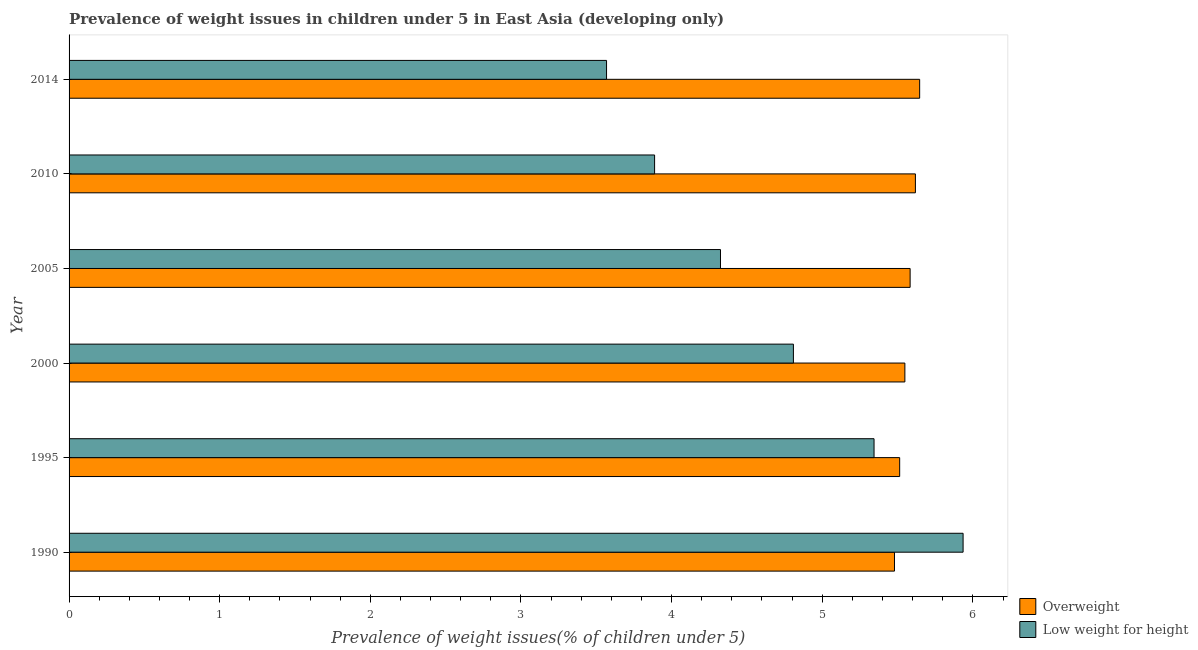How many bars are there on the 2nd tick from the bottom?
Ensure brevity in your answer.  2. What is the label of the 2nd group of bars from the top?
Offer a terse response. 2010. What is the percentage of overweight children in 2005?
Provide a succinct answer. 5.58. Across all years, what is the maximum percentage of underweight children?
Ensure brevity in your answer.  5.93. Across all years, what is the minimum percentage of underweight children?
Your answer should be very brief. 3.57. In which year was the percentage of overweight children maximum?
Give a very brief answer. 2014. In which year was the percentage of overweight children minimum?
Ensure brevity in your answer.  1990. What is the total percentage of underweight children in the graph?
Provide a succinct answer. 27.87. What is the difference between the percentage of overweight children in 2005 and that in 2010?
Offer a very short reply. -0.04. What is the difference between the percentage of underweight children in 2014 and the percentage of overweight children in 1990?
Your answer should be compact. -1.91. What is the average percentage of underweight children per year?
Keep it short and to the point. 4.64. In the year 2014, what is the difference between the percentage of overweight children and percentage of underweight children?
Ensure brevity in your answer.  2.08. In how many years, is the percentage of overweight children greater than 4.4 %?
Keep it short and to the point. 6. What is the ratio of the percentage of underweight children in 1990 to that in 2000?
Offer a very short reply. 1.23. What is the difference between the highest and the second highest percentage of overweight children?
Your answer should be compact. 0.03. What is the difference between the highest and the lowest percentage of underweight children?
Your answer should be very brief. 2.37. In how many years, is the percentage of overweight children greater than the average percentage of overweight children taken over all years?
Provide a short and direct response. 3. What does the 1st bar from the top in 2005 represents?
Keep it short and to the point. Low weight for height. What does the 2nd bar from the bottom in 2000 represents?
Give a very brief answer. Low weight for height. How many bars are there?
Give a very brief answer. 12. Are all the bars in the graph horizontal?
Provide a short and direct response. Yes. Are the values on the major ticks of X-axis written in scientific E-notation?
Make the answer very short. No. Does the graph contain grids?
Your answer should be compact. No. How many legend labels are there?
Give a very brief answer. 2. How are the legend labels stacked?
Provide a succinct answer. Vertical. What is the title of the graph?
Give a very brief answer. Prevalence of weight issues in children under 5 in East Asia (developing only). What is the label or title of the X-axis?
Offer a very short reply. Prevalence of weight issues(% of children under 5). What is the Prevalence of weight issues(% of children under 5) in Overweight in 1990?
Your answer should be compact. 5.48. What is the Prevalence of weight issues(% of children under 5) of Low weight for height in 1990?
Your answer should be compact. 5.93. What is the Prevalence of weight issues(% of children under 5) in Overweight in 1995?
Your answer should be compact. 5.51. What is the Prevalence of weight issues(% of children under 5) of Low weight for height in 1995?
Keep it short and to the point. 5.34. What is the Prevalence of weight issues(% of children under 5) in Overweight in 2000?
Your answer should be compact. 5.55. What is the Prevalence of weight issues(% of children under 5) in Low weight for height in 2000?
Ensure brevity in your answer.  4.81. What is the Prevalence of weight issues(% of children under 5) of Overweight in 2005?
Give a very brief answer. 5.58. What is the Prevalence of weight issues(% of children under 5) of Low weight for height in 2005?
Your answer should be compact. 4.32. What is the Prevalence of weight issues(% of children under 5) in Overweight in 2010?
Offer a very short reply. 5.62. What is the Prevalence of weight issues(% of children under 5) in Low weight for height in 2010?
Your response must be concise. 3.89. What is the Prevalence of weight issues(% of children under 5) of Overweight in 2014?
Ensure brevity in your answer.  5.65. What is the Prevalence of weight issues(% of children under 5) of Low weight for height in 2014?
Offer a terse response. 3.57. Across all years, what is the maximum Prevalence of weight issues(% of children under 5) of Overweight?
Provide a short and direct response. 5.65. Across all years, what is the maximum Prevalence of weight issues(% of children under 5) in Low weight for height?
Your answer should be compact. 5.93. Across all years, what is the minimum Prevalence of weight issues(% of children under 5) in Overweight?
Offer a very short reply. 5.48. Across all years, what is the minimum Prevalence of weight issues(% of children under 5) of Low weight for height?
Provide a succinct answer. 3.57. What is the total Prevalence of weight issues(% of children under 5) in Overweight in the graph?
Offer a very short reply. 33.39. What is the total Prevalence of weight issues(% of children under 5) in Low weight for height in the graph?
Your response must be concise. 27.87. What is the difference between the Prevalence of weight issues(% of children under 5) of Overweight in 1990 and that in 1995?
Keep it short and to the point. -0.03. What is the difference between the Prevalence of weight issues(% of children under 5) in Low weight for height in 1990 and that in 1995?
Offer a very short reply. 0.59. What is the difference between the Prevalence of weight issues(% of children under 5) of Overweight in 1990 and that in 2000?
Your answer should be very brief. -0.07. What is the difference between the Prevalence of weight issues(% of children under 5) in Low weight for height in 1990 and that in 2000?
Offer a very short reply. 1.13. What is the difference between the Prevalence of weight issues(% of children under 5) in Overweight in 1990 and that in 2005?
Give a very brief answer. -0.1. What is the difference between the Prevalence of weight issues(% of children under 5) of Low weight for height in 1990 and that in 2005?
Give a very brief answer. 1.61. What is the difference between the Prevalence of weight issues(% of children under 5) of Overweight in 1990 and that in 2010?
Provide a succinct answer. -0.14. What is the difference between the Prevalence of weight issues(% of children under 5) of Low weight for height in 1990 and that in 2010?
Provide a short and direct response. 2.05. What is the difference between the Prevalence of weight issues(% of children under 5) of Overweight in 1990 and that in 2014?
Your answer should be very brief. -0.17. What is the difference between the Prevalence of weight issues(% of children under 5) in Low weight for height in 1990 and that in 2014?
Provide a short and direct response. 2.37. What is the difference between the Prevalence of weight issues(% of children under 5) of Overweight in 1995 and that in 2000?
Your answer should be very brief. -0.03. What is the difference between the Prevalence of weight issues(% of children under 5) in Low weight for height in 1995 and that in 2000?
Provide a succinct answer. 0.54. What is the difference between the Prevalence of weight issues(% of children under 5) of Overweight in 1995 and that in 2005?
Offer a terse response. -0.07. What is the difference between the Prevalence of weight issues(% of children under 5) of Low weight for height in 1995 and that in 2005?
Offer a terse response. 1.02. What is the difference between the Prevalence of weight issues(% of children under 5) of Overweight in 1995 and that in 2010?
Your answer should be very brief. -0.1. What is the difference between the Prevalence of weight issues(% of children under 5) of Low weight for height in 1995 and that in 2010?
Make the answer very short. 1.46. What is the difference between the Prevalence of weight issues(% of children under 5) in Overweight in 1995 and that in 2014?
Make the answer very short. -0.13. What is the difference between the Prevalence of weight issues(% of children under 5) of Low weight for height in 1995 and that in 2014?
Your answer should be compact. 1.78. What is the difference between the Prevalence of weight issues(% of children under 5) in Overweight in 2000 and that in 2005?
Keep it short and to the point. -0.03. What is the difference between the Prevalence of weight issues(% of children under 5) in Low weight for height in 2000 and that in 2005?
Keep it short and to the point. 0.48. What is the difference between the Prevalence of weight issues(% of children under 5) in Overweight in 2000 and that in 2010?
Offer a terse response. -0.07. What is the difference between the Prevalence of weight issues(% of children under 5) of Low weight for height in 2000 and that in 2010?
Keep it short and to the point. 0.92. What is the difference between the Prevalence of weight issues(% of children under 5) of Overweight in 2000 and that in 2014?
Offer a very short reply. -0.1. What is the difference between the Prevalence of weight issues(% of children under 5) in Low weight for height in 2000 and that in 2014?
Provide a succinct answer. 1.24. What is the difference between the Prevalence of weight issues(% of children under 5) of Overweight in 2005 and that in 2010?
Give a very brief answer. -0.04. What is the difference between the Prevalence of weight issues(% of children under 5) in Low weight for height in 2005 and that in 2010?
Your answer should be very brief. 0.44. What is the difference between the Prevalence of weight issues(% of children under 5) of Overweight in 2005 and that in 2014?
Offer a very short reply. -0.06. What is the difference between the Prevalence of weight issues(% of children under 5) in Low weight for height in 2005 and that in 2014?
Your response must be concise. 0.76. What is the difference between the Prevalence of weight issues(% of children under 5) of Overweight in 2010 and that in 2014?
Your answer should be compact. -0.03. What is the difference between the Prevalence of weight issues(% of children under 5) in Low weight for height in 2010 and that in 2014?
Give a very brief answer. 0.32. What is the difference between the Prevalence of weight issues(% of children under 5) in Overweight in 1990 and the Prevalence of weight issues(% of children under 5) in Low weight for height in 1995?
Your answer should be compact. 0.14. What is the difference between the Prevalence of weight issues(% of children under 5) in Overweight in 1990 and the Prevalence of weight issues(% of children under 5) in Low weight for height in 2000?
Give a very brief answer. 0.67. What is the difference between the Prevalence of weight issues(% of children under 5) in Overweight in 1990 and the Prevalence of weight issues(% of children under 5) in Low weight for height in 2005?
Give a very brief answer. 1.16. What is the difference between the Prevalence of weight issues(% of children under 5) in Overweight in 1990 and the Prevalence of weight issues(% of children under 5) in Low weight for height in 2010?
Offer a very short reply. 1.59. What is the difference between the Prevalence of weight issues(% of children under 5) of Overweight in 1990 and the Prevalence of weight issues(% of children under 5) of Low weight for height in 2014?
Your response must be concise. 1.91. What is the difference between the Prevalence of weight issues(% of children under 5) of Overweight in 1995 and the Prevalence of weight issues(% of children under 5) of Low weight for height in 2000?
Offer a terse response. 0.71. What is the difference between the Prevalence of weight issues(% of children under 5) of Overweight in 1995 and the Prevalence of weight issues(% of children under 5) of Low weight for height in 2005?
Offer a very short reply. 1.19. What is the difference between the Prevalence of weight issues(% of children under 5) in Overweight in 1995 and the Prevalence of weight issues(% of children under 5) in Low weight for height in 2010?
Keep it short and to the point. 1.63. What is the difference between the Prevalence of weight issues(% of children under 5) of Overweight in 1995 and the Prevalence of weight issues(% of children under 5) of Low weight for height in 2014?
Offer a terse response. 1.95. What is the difference between the Prevalence of weight issues(% of children under 5) of Overweight in 2000 and the Prevalence of weight issues(% of children under 5) of Low weight for height in 2005?
Give a very brief answer. 1.22. What is the difference between the Prevalence of weight issues(% of children under 5) in Overweight in 2000 and the Prevalence of weight issues(% of children under 5) in Low weight for height in 2010?
Your response must be concise. 1.66. What is the difference between the Prevalence of weight issues(% of children under 5) in Overweight in 2000 and the Prevalence of weight issues(% of children under 5) in Low weight for height in 2014?
Your answer should be compact. 1.98. What is the difference between the Prevalence of weight issues(% of children under 5) of Overweight in 2005 and the Prevalence of weight issues(% of children under 5) of Low weight for height in 2010?
Keep it short and to the point. 1.7. What is the difference between the Prevalence of weight issues(% of children under 5) in Overweight in 2005 and the Prevalence of weight issues(% of children under 5) in Low weight for height in 2014?
Your answer should be very brief. 2.02. What is the difference between the Prevalence of weight issues(% of children under 5) in Overweight in 2010 and the Prevalence of weight issues(% of children under 5) in Low weight for height in 2014?
Your answer should be very brief. 2.05. What is the average Prevalence of weight issues(% of children under 5) in Overweight per year?
Make the answer very short. 5.57. What is the average Prevalence of weight issues(% of children under 5) of Low weight for height per year?
Provide a short and direct response. 4.64. In the year 1990, what is the difference between the Prevalence of weight issues(% of children under 5) in Overweight and Prevalence of weight issues(% of children under 5) in Low weight for height?
Your answer should be compact. -0.46. In the year 1995, what is the difference between the Prevalence of weight issues(% of children under 5) of Overweight and Prevalence of weight issues(% of children under 5) of Low weight for height?
Your answer should be compact. 0.17. In the year 2000, what is the difference between the Prevalence of weight issues(% of children under 5) of Overweight and Prevalence of weight issues(% of children under 5) of Low weight for height?
Provide a succinct answer. 0.74. In the year 2005, what is the difference between the Prevalence of weight issues(% of children under 5) in Overweight and Prevalence of weight issues(% of children under 5) in Low weight for height?
Provide a short and direct response. 1.26. In the year 2010, what is the difference between the Prevalence of weight issues(% of children under 5) of Overweight and Prevalence of weight issues(% of children under 5) of Low weight for height?
Ensure brevity in your answer.  1.73. In the year 2014, what is the difference between the Prevalence of weight issues(% of children under 5) in Overweight and Prevalence of weight issues(% of children under 5) in Low weight for height?
Provide a succinct answer. 2.08. What is the ratio of the Prevalence of weight issues(% of children under 5) of Low weight for height in 1990 to that in 1995?
Your response must be concise. 1.11. What is the ratio of the Prevalence of weight issues(% of children under 5) of Overweight in 1990 to that in 2000?
Your answer should be compact. 0.99. What is the ratio of the Prevalence of weight issues(% of children under 5) in Low weight for height in 1990 to that in 2000?
Your response must be concise. 1.23. What is the ratio of the Prevalence of weight issues(% of children under 5) of Overweight in 1990 to that in 2005?
Your answer should be compact. 0.98. What is the ratio of the Prevalence of weight issues(% of children under 5) of Low weight for height in 1990 to that in 2005?
Keep it short and to the point. 1.37. What is the ratio of the Prevalence of weight issues(% of children under 5) in Overweight in 1990 to that in 2010?
Offer a very short reply. 0.98. What is the ratio of the Prevalence of weight issues(% of children under 5) of Low weight for height in 1990 to that in 2010?
Offer a terse response. 1.53. What is the ratio of the Prevalence of weight issues(% of children under 5) of Overweight in 1990 to that in 2014?
Provide a short and direct response. 0.97. What is the ratio of the Prevalence of weight issues(% of children under 5) of Low weight for height in 1990 to that in 2014?
Provide a succinct answer. 1.66. What is the ratio of the Prevalence of weight issues(% of children under 5) in Overweight in 1995 to that in 2000?
Your response must be concise. 0.99. What is the ratio of the Prevalence of weight issues(% of children under 5) in Low weight for height in 1995 to that in 2000?
Make the answer very short. 1.11. What is the ratio of the Prevalence of weight issues(% of children under 5) in Overweight in 1995 to that in 2005?
Your answer should be compact. 0.99. What is the ratio of the Prevalence of weight issues(% of children under 5) in Low weight for height in 1995 to that in 2005?
Provide a succinct answer. 1.24. What is the ratio of the Prevalence of weight issues(% of children under 5) in Overweight in 1995 to that in 2010?
Provide a short and direct response. 0.98. What is the ratio of the Prevalence of weight issues(% of children under 5) in Low weight for height in 1995 to that in 2010?
Keep it short and to the point. 1.37. What is the ratio of the Prevalence of weight issues(% of children under 5) in Overweight in 1995 to that in 2014?
Give a very brief answer. 0.98. What is the ratio of the Prevalence of weight issues(% of children under 5) of Low weight for height in 1995 to that in 2014?
Keep it short and to the point. 1.5. What is the ratio of the Prevalence of weight issues(% of children under 5) in Overweight in 2000 to that in 2005?
Provide a succinct answer. 0.99. What is the ratio of the Prevalence of weight issues(% of children under 5) of Low weight for height in 2000 to that in 2005?
Give a very brief answer. 1.11. What is the ratio of the Prevalence of weight issues(% of children under 5) of Overweight in 2000 to that in 2010?
Your answer should be very brief. 0.99. What is the ratio of the Prevalence of weight issues(% of children under 5) of Low weight for height in 2000 to that in 2010?
Give a very brief answer. 1.24. What is the ratio of the Prevalence of weight issues(% of children under 5) of Overweight in 2000 to that in 2014?
Your answer should be very brief. 0.98. What is the ratio of the Prevalence of weight issues(% of children under 5) in Low weight for height in 2000 to that in 2014?
Keep it short and to the point. 1.35. What is the ratio of the Prevalence of weight issues(% of children under 5) of Overweight in 2005 to that in 2010?
Ensure brevity in your answer.  0.99. What is the ratio of the Prevalence of weight issues(% of children under 5) of Low weight for height in 2005 to that in 2010?
Your answer should be compact. 1.11. What is the ratio of the Prevalence of weight issues(% of children under 5) of Overweight in 2005 to that in 2014?
Give a very brief answer. 0.99. What is the ratio of the Prevalence of weight issues(% of children under 5) in Low weight for height in 2005 to that in 2014?
Your answer should be compact. 1.21. What is the ratio of the Prevalence of weight issues(% of children under 5) of Overweight in 2010 to that in 2014?
Give a very brief answer. 0.99. What is the ratio of the Prevalence of weight issues(% of children under 5) in Low weight for height in 2010 to that in 2014?
Your response must be concise. 1.09. What is the difference between the highest and the second highest Prevalence of weight issues(% of children under 5) in Overweight?
Provide a succinct answer. 0.03. What is the difference between the highest and the second highest Prevalence of weight issues(% of children under 5) of Low weight for height?
Your answer should be very brief. 0.59. What is the difference between the highest and the lowest Prevalence of weight issues(% of children under 5) of Overweight?
Keep it short and to the point. 0.17. What is the difference between the highest and the lowest Prevalence of weight issues(% of children under 5) in Low weight for height?
Ensure brevity in your answer.  2.37. 